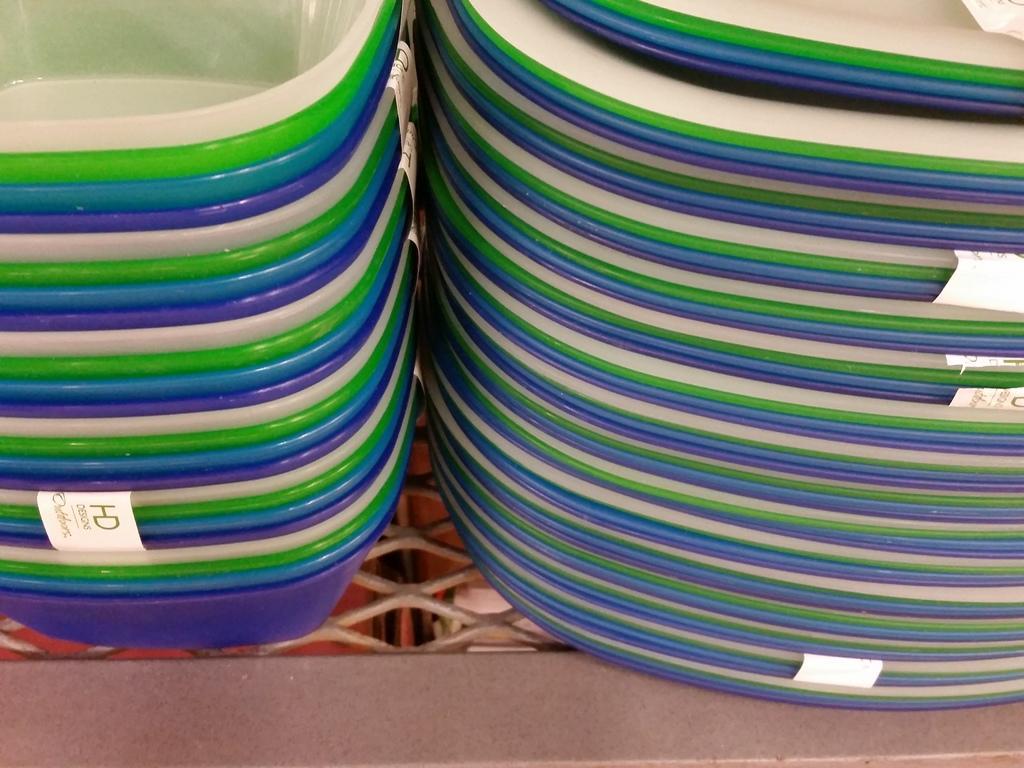Describe this image in one or two sentences. In this picture, there are bowls and plates which are in different colors. 